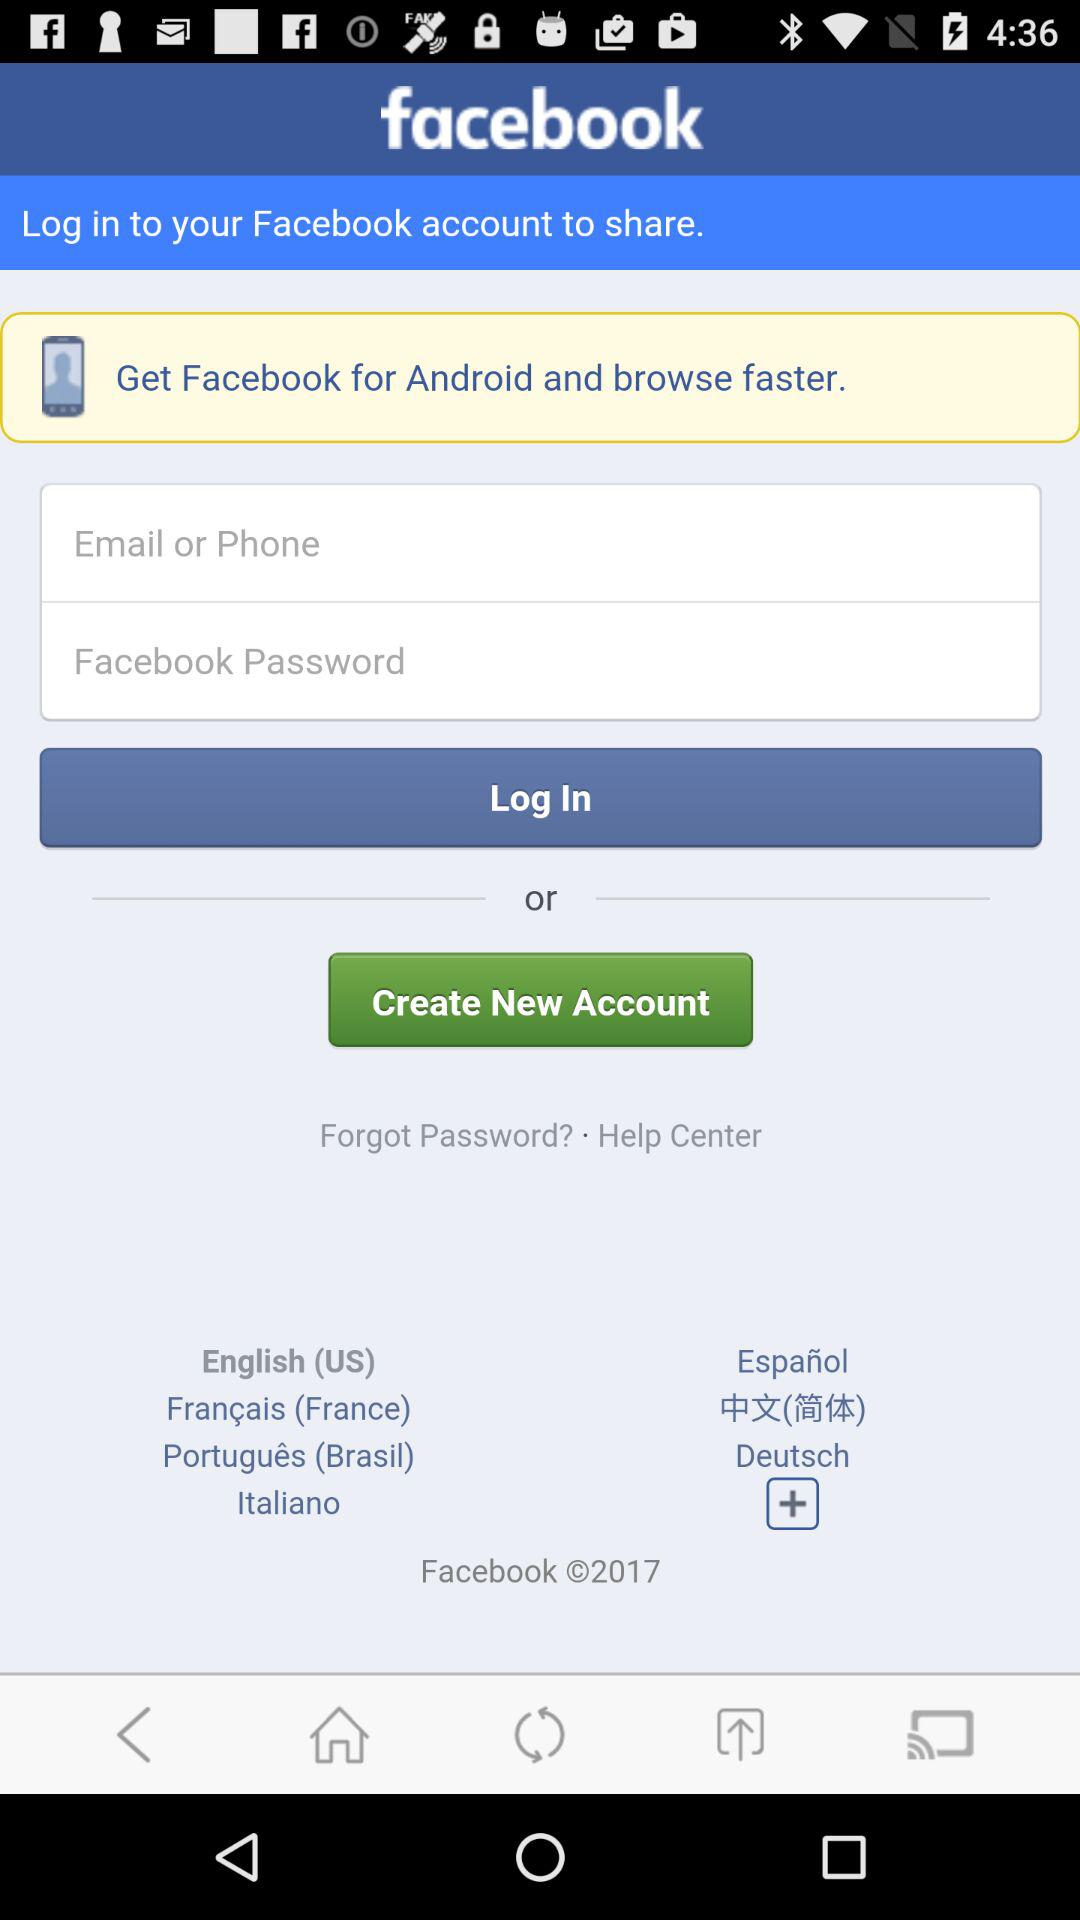What do we need to do to browse faster? We need "Facebook for Android" to browse faster. 